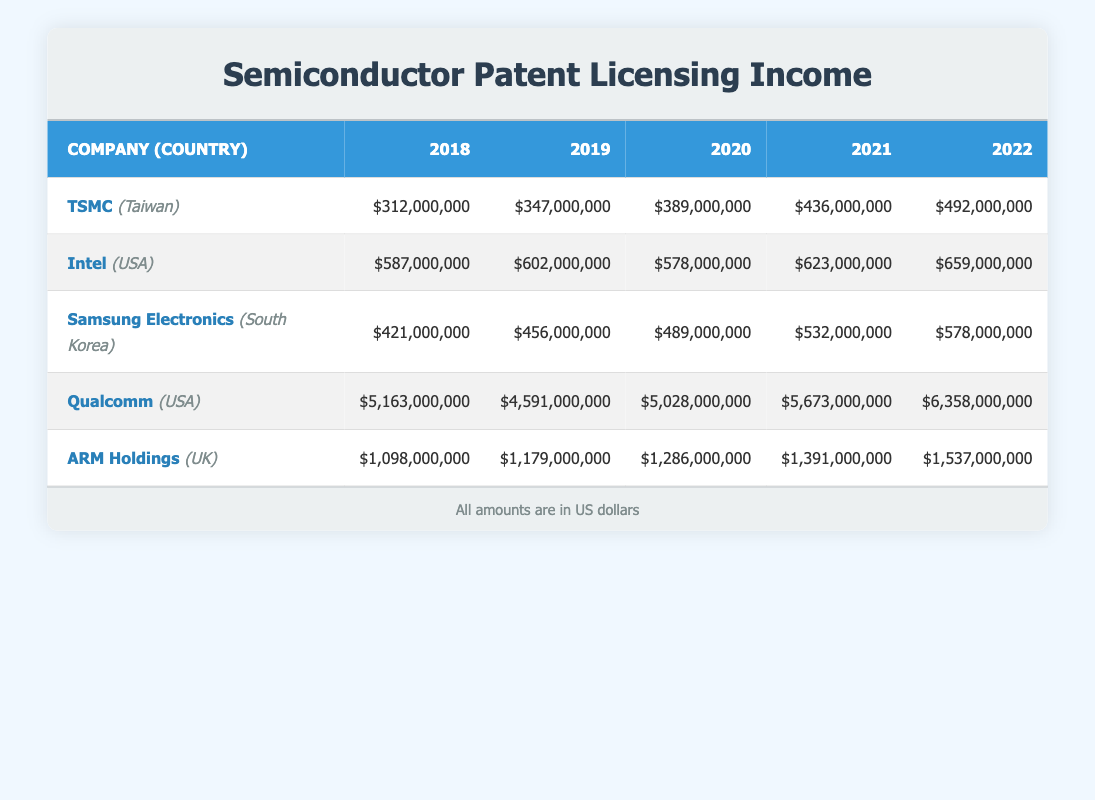What was the total licensing fee income for Qualcomm in 2021? The licensing fee income for Qualcomm in 2021 is stated in the table as $5,673,000,000.
Answer: $5,673,000,000 Which company had the highest licensing income in 2020? Referring to the table, Qualcomm had the highest licensing income in 2020 with $5,028,000,000, compared to Intel ($578,000,000), TSMC ($389,000,000), Samsung ($489,000,000), and ARM Holdings ($1,286,000,000).
Answer: Qualcomm What is the percentage increase in licensing fee income for Intel from 2019 to 2022? To calculate the percentage increase, first find the difference: $659,000,000 (2022) - $602,000,000 (2019) = $57,000,000. Then divide this by the 2019 amount: $57,000,000 / $602,000,000 ≈ 0.0947. Finally, multiply by 100 to get the percentage: 0.0947 * 100 ≈ 9.47%.
Answer: 9.47% Did TSMC's licensing fee income increase every year from 2018 to 2022? By checking the values for TSMC year by year: $312,000,000 (2018), $347,000,000 (2019), $389,000,000 (2020), $436,000,000 (2021), and $492,000,000 (2022), all values show a consistent increase each year.
Answer: Yes What was the average licensing income across all companies in 2021? First, sum the licensing incomes for all companies in 2021: $436,000,000 (TSMC) + $623,000,000 (Intel) + $532,000,000 (Samsung) + $5,673,000,000 (Qualcomm) + $1,391,000,000 (ARM) = $8,655,000,000. Then divide by the number of companies (5) to find the average: $8,655,000,000 / 5 = $1,731,000,000.
Answer: $1,731,000,000 Which company experienced a decrease in licensing income from 2018 to 2019? Evaluating the table, Qualcomm's income decreased from $5,163,000,000 (2018) to $4,591,000,000 (2019). The other companies had increases or stayed the same.
Answer: Qualcomm What is the total licensing income for Samsung Electronics over the 5-year period? To find the total, add the income from each year: $421,000,000 (2018) + $456,000,000 (2019) + $489,000,000 (2020) + $532,000,000 (2021) + $578,000,000 (2022) = $2,476,000,000.
Answer: $2,476,000,000 Did all companies have licensing income above $1 billion in 2021? Checking the income values for 2021: TSMC ($436,000,000), Intel ($623,000,000), Samsung ($532,000,000), Qualcomm ($5,673,000,000), ARM Holdings ($1,391,000,000) reveals that TSMC and Intel were below $1 billion.
Answer: No What was the year-over-year average growth rate of ARM Holdings' licensing income from 2018 to 2022? Calculate the year-on-year growth rates: (1179000000 - 1098000000) / 1098000000 ≈ 0.0100 (2019), (1286000000 - 1179000000) / 1179000000 ≈ 0.0059 (2020), (1391000000 - 1286000000) / 1286000000 ≈ 0.0117 (2021), (1537000000 - 1391000000) / 1391000000 ≈ 0.0104 (2022). The average of these rates is approximately (0.0100 + 0.0059 + 0.0117 + 0.0104) / 4 ≈ 0.0095 or 0.95%.
Answer: 0.95% 